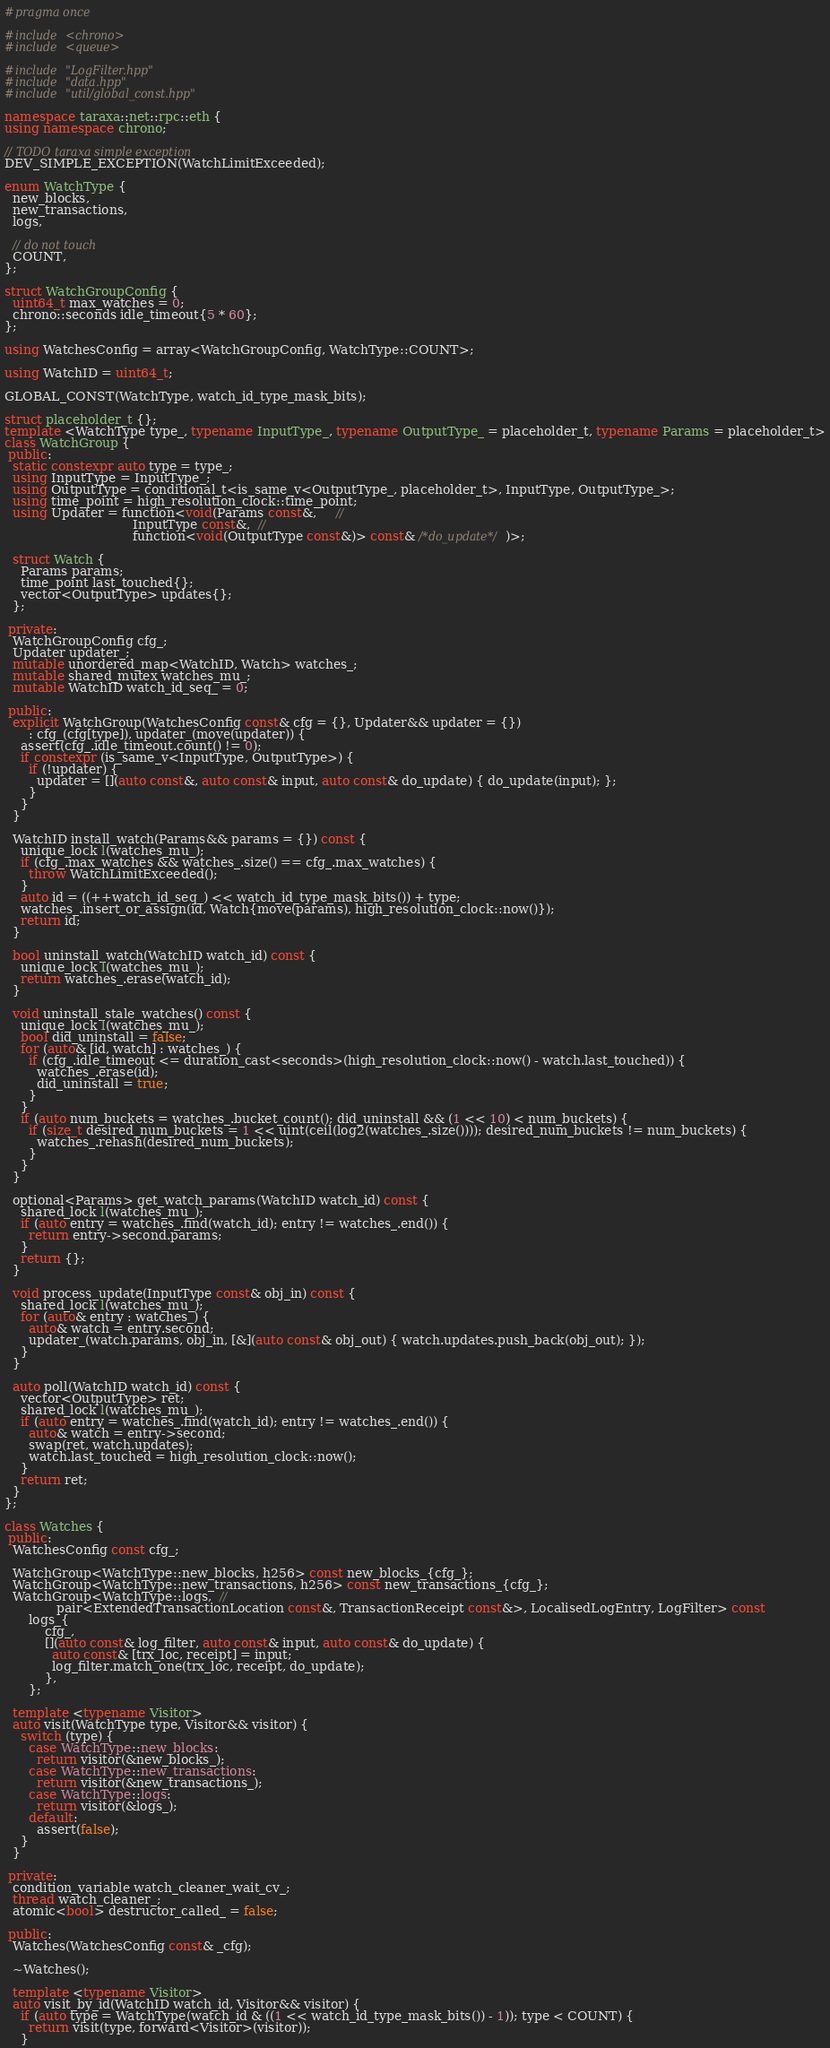Convert code to text. <code><loc_0><loc_0><loc_500><loc_500><_C++_>#pragma once

#include <chrono>
#include <queue>

#include "LogFilter.hpp"
#include "data.hpp"
#include "util/global_const.hpp"

namespace taraxa::net::rpc::eth {
using namespace chrono;

// TODO taraxa simple exception
DEV_SIMPLE_EXCEPTION(WatchLimitExceeded);

enum WatchType {
  new_blocks,
  new_transactions,
  logs,

  // do not touch
  COUNT,
};

struct WatchGroupConfig {
  uint64_t max_watches = 0;
  chrono::seconds idle_timeout{5 * 60};
};

using WatchesConfig = array<WatchGroupConfig, WatchType::COUNT>;

using WatchID = uint64_t;

GLOBAL_CONST(WatchType, watch_id_type_mask_bits);

struct placeholder_t {};
template <WatchType type_, typename InputType_, typename OutputType_ = placeholder_t, typename Params = placeholder_t>
class WatchGroup {
 public:
  static constexpr auto type = type_;
  using InputType = InputType_;
  using OutputType = conditional_t<is_same_v<OutputType_, placeholder_t>, InputType, OutputType_>;
  using time_point = high_resolution_clock::time_point;
  using Updater = function<void(Params const&,     //
                                InputType const&,  //
                                function<void(OutputType const&)> const& /*do_update*/)>;

  struct Watch {
    Params params;
    time_point last_touched{};
    vector<OutputType> updates{};
  };

 private:
  WatchGroupConfig cfg_;
  Updater updater_;
  mutable unordered_map<WatchID, Watch> watches_;
  mutable shared_mutex watches_mu_;
  mutable WatchID watch_id_seq_ = 0;

 public:
  explicit WatchGroup(WatchesConfig const& cfg = {}, Updater&& updater = {})
      : cfg_(cfg[type]), updater_(move(updater)) {
    assert(cfg_.idle_timeout.count() != 0);
    if constexpr (is_same_v<InputType, OutputType>) {
      if (!updater) {
        updater = [](auto const&, auto const& input, auto const& do_update) { do_update(input); };
      }
    }
  }

  WatchID install_watch(Params&& params = {}) const {
    unique_lock l(watches_mu_);
    if (cfg_.max_watches && watches_.size() == cfg_.max_watches) {
      throw WatchLimitExceeded();
    }
    auto id = ((++watch_id_seq_) << watch_id_type_mask_bits()) + type;
    watches_.insert_or_assign(id, Watch{move(params), high_resolution_clock::now()});
    return id;
  }

  bool uninstall_watch(WatchID watch_id) const {
    unique_lock l(watches_mu_);
    return watches_.erase(watch_id);
  }

  void uninstall_stale_watches() const {
    unique_lock l(watches_mu_);
    bool did_uninstall = false;
    for (auto& [id, watch] : watches_) {
      if (cfg_.idle_timeout <= duration_cast<seconds>(high_resolution_clock::now() - watch.last_touched)) {
        watches_.erase(id);
        did_uninstall = true;
      }
    }
    if (auto num_buckets = watches_.bucket_count(); did_uninstall && (1 << 10) < num_buckets) {
      if (size_t desired_num_buckets = 1 << uint(ceil(log2(watches_.size()))); desired_num_buckets != num_buckets) {
        watches_.rehash(desired_num_buckets);
      }
    }
  }

  optional<Params> get_watch_params(WatchID watch_id) const {
    shared_lock l(watches_mu_);
    if (auto entry = watches_.find(watch_id); entry != watches_.end()) {
      return entry->second.params;
    }
    return {};
  }

  void process_update(InputType const& obj_in) const {
    shared_lock l(watches_mu_);
    for (auto& entry : watches_) {
      auto& watch = entry.second;
      updater_(watch.params, obj_in, [&](auto const& obj_out) { watch.updates.push_back(obj_out); });
    }
  }

  auto poll(WatchID watch_id) const {
    vector<OutputType> ret;
    shared_lock l(watches_mu_);
    if (auto entry = watches_.find(watch_id); entry != watches_.end()) {
      auto& watch = entry->second;
      swap(ret, watch.updates);
      watch.last_touched = high_resolution_clock::now();
    }
    return ret;
  }
};

class Watches {
 public:
  WatchesConfig const cfg_;

  WatchGroup<WatchType::new_blocks, h256> const new_blocks_{cfg_};
  WatchGroup<WatchType::new_transactions, h256> const new_transactions_{cfg_};
  WatchGroup<WatchType::logs,  //
             pair<ExtendedTransactionLocation const&, TransactionReceipt const&>, LocalisedLogEntry, LogFilter> const
      logs_{
          cfg_,
          [](auto const& log_filter, auto const& input, auto const& do_update) {
            auto const& [trx_loc, receipt] = input;
            log_filter.match_one(trx_loc, receipt, do_update);
          },
      };

  template <typename Visitor>
  auto visit(WatchType type, Visitor&& visitor) {
    switch (type) {
      case WatchType::new_blocks:
        return visitor(&new_blocks_);
      case WatchType::new_transactions:
        return visitor(&new_transactions_);
      case WatchType::logs:
        return visitor(&logs_);
      default:
        assert(false);
    }
  }

 private:
  condition_variable watch_cleaner_wait_cv_;
  thread watch_cleaner_;
  atomic<bool> destructor_called_ = false;

 public:
  Watches(WatchesConfig const& _cfg);

  ~Watches();

  template <typename Visitor>
  auto visit_by_id(WatchID watch_id, Visitor&& visitor) {
    if (auto type = WatchType(watch_id & ((1 << watch_id_type_mask_bits()) - 1)); type < COUNT) {
      return visit(type, forward<Visitor>(visitor));
    }</code> 